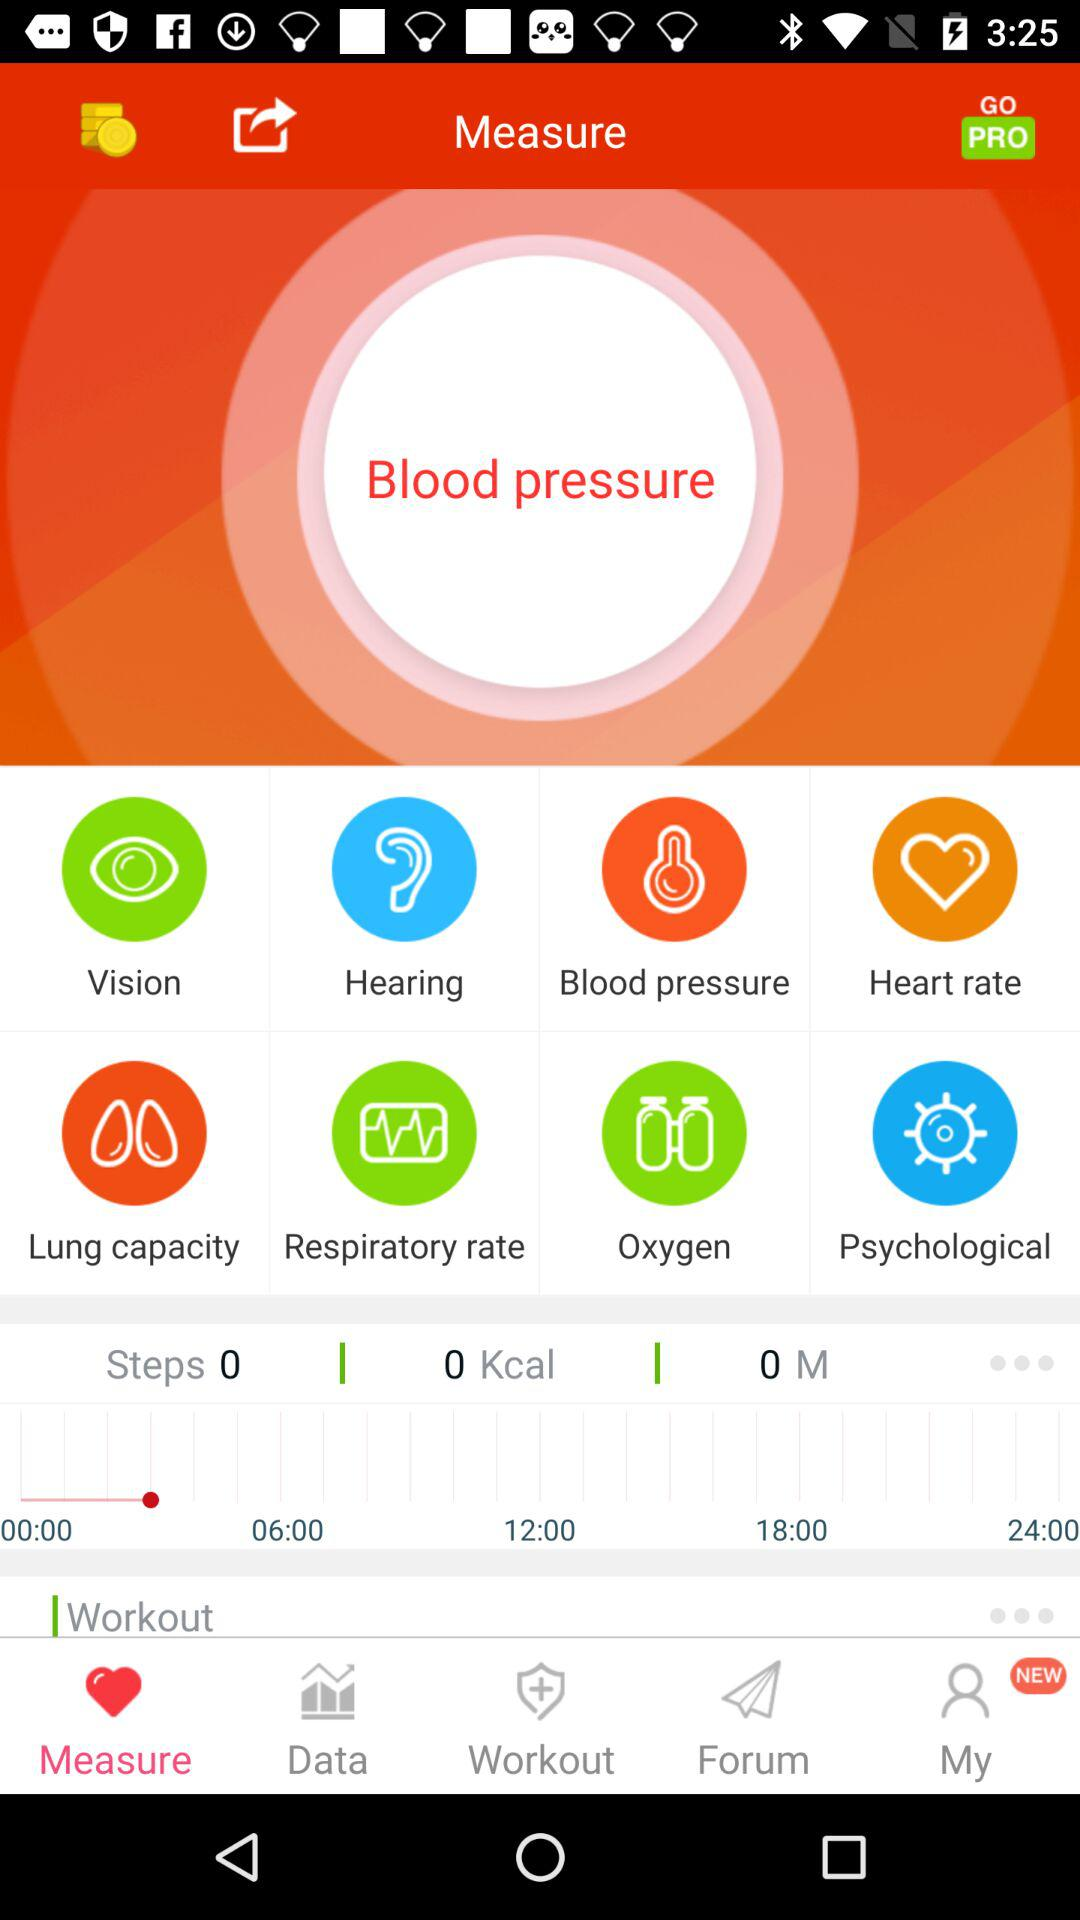Which tab is currently selected? The currently selected tab is "Measure". 